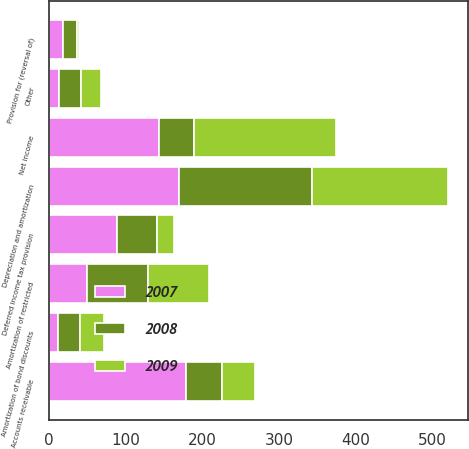<chart> <loc_0><loc_0><loc_500><loc_500><stacked_bar_chart><ecel><fcel>Net income<fcel>Depreciation and amortization<fcel>Provision for (reversal of)<fcel>Amortization of restricted<fcel>Amortization of bond discounts<fcel>Deferred income tax provision<fcel>Other<fcel>Accounts receivable<nl><fcel>2007<fcel>143.4<fcel>169.9<fcel>19.3<fcel>49.5<fcel>12.1<fcel>89.2<fcel>13.4<fcel>179.5<nl><fcel>2008<fcel>46.5<fcel>173.3<fcel>17<fcel>80.1<fcel>28.7<fcel>51.9<fcel>29<fcel>46.5<nl><fcel>2009<fcel>184.3<fcel>177.2<fcel>3.6<fcel>79.7<fcel>30.8<fcel>22.4<fcel>25.2<fcel>43.5<nl></chart> 